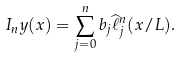<formula> <loc_0><loc_0><loc_500><loc_500>I _ { n } y ( x ) = \sum _ { j = 0 } ^ { n } b _ { j } \widehat { \ell } ^ { n } _ { j } ( x / L ) .</formula> 